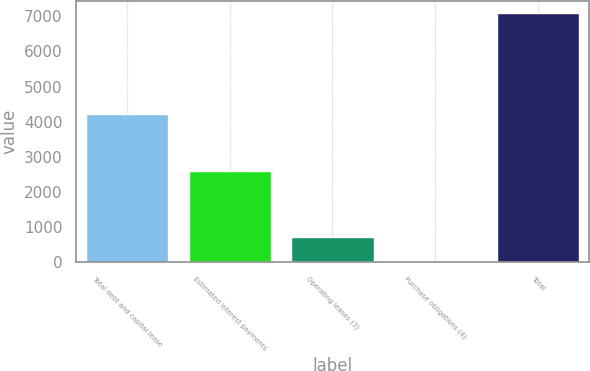Convert chart. <chart><loc_0><loc_0><loc_500><loc_500><bar_chart><fcel>Total debt and capital lease<fcel>Estimated interest payments<fcel>Operating leases (3)<fcel>Purchase obligations (4)<fcel>Total<nl><fcel>4213<fcel>2600<fcel>715.9<fcel>8<fcel>7087<nl></chart> 